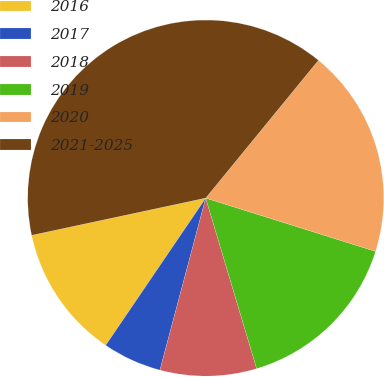<chart> <loc_0><loc_0><loc_500><loc_500><pie_chart><fcel>2016<fcel>2017<fcel>2018<fcel>2019<fcel>2020<fcel>2021-2025<nl><fcel>12.15%<fcel>5.36%<fcel>8.76%<fcel>15.54%<fcel>18.93%<fcel>39.27%<nl></chart> 